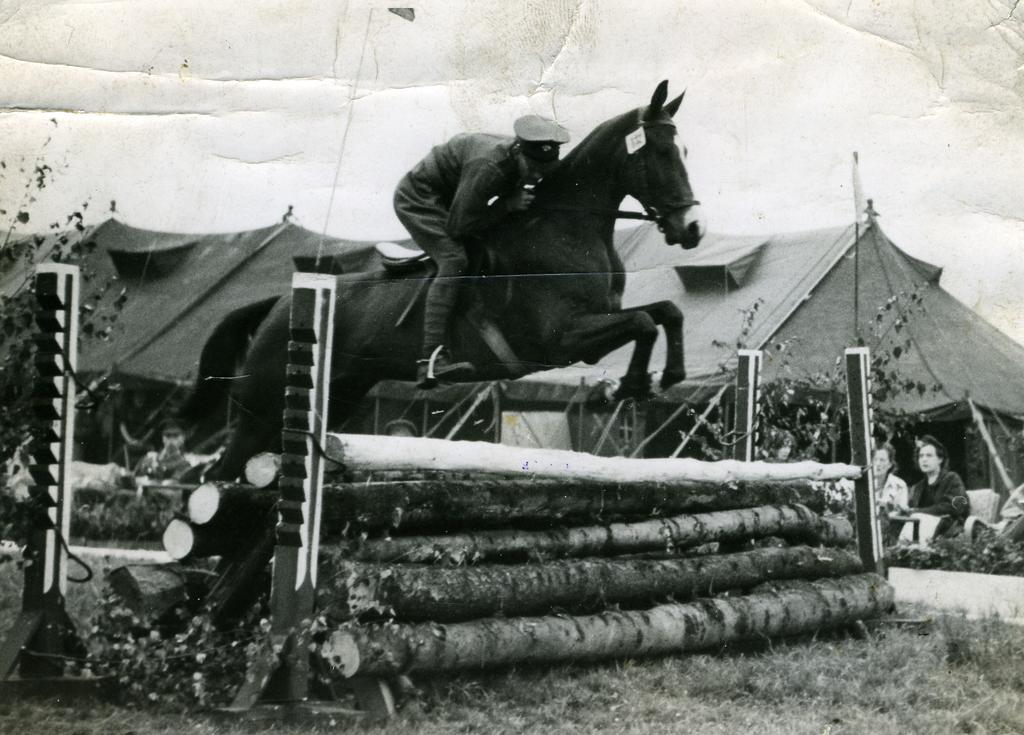Can you describe this image briefly? In this picture we can see a person riding a horse, at the bottom there is grass, in the background there is a tent, we can see two persons sitting here, on the left side there is a plant, we can see wood here. 